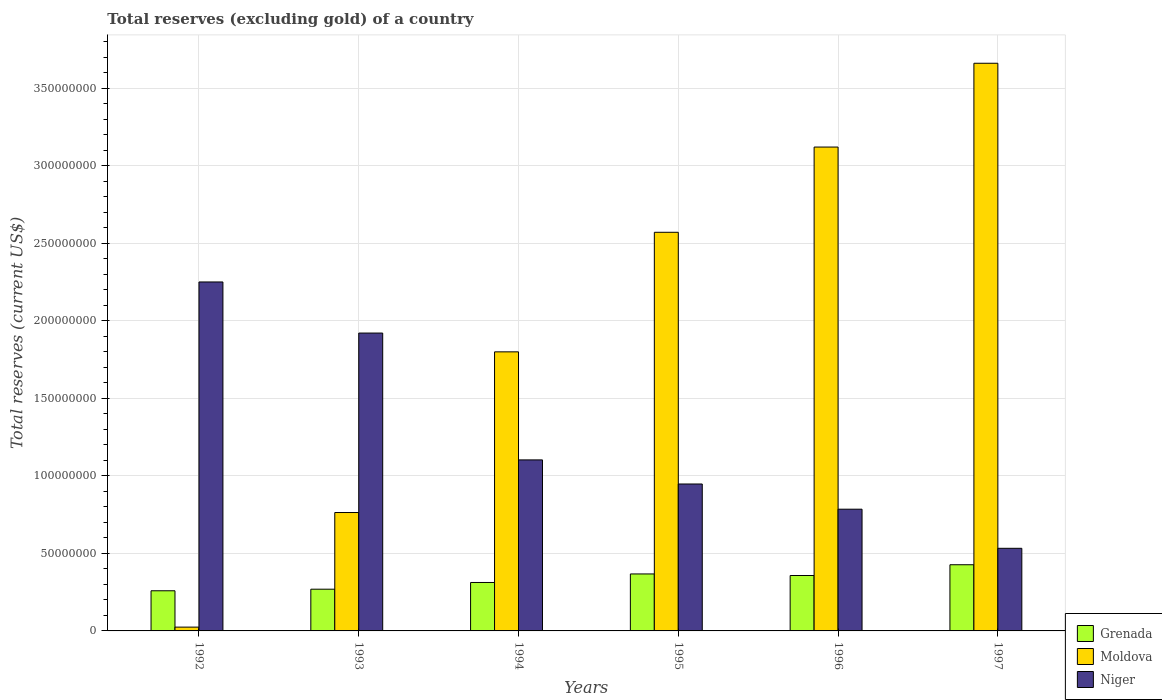How many groups of bars are there?
Offer a terse response. 6. Are the number of bars per tick equal to the number of legend labels?
Ensure brevity in your answer.  Yes. How many bars are there on the 4th tick from the left?
Your answer should be compact. 3. How many bars are there on the 6th tick from the right?
Your answer should be very brief. 3. What is the label of the 5th group of bars from the left?
Ensure brevity in your answer.  1996. In how many cases, is the number of bars for a given year not equal to the number of legend labels?
Provide a succinct answer. 0. What is the total reserves (excluding gold) in Niger in 1993?
Make the answer very short. 1.92e+08. Across all years, what is the maximum total reserves (excluding gold) in Niger?
Offer a terse response. 2.25e+08. Across all years, what is the minimum total reserves (excluding gold) in Moldova?
Make the answer very short. 2.45e+06. In which year was the total reserves (excluding gold) in Niger minimum?
Your response must be concise. 1997. What is the total total reserves (excluding gold) in Moldova in the graph?
Provide a short and direct response. 1.19e+09. What is the difference between the total reserves (excluding gold) in Niger in 1994 and that in 1997?
Your response must be concise. 5.70e+07. What is the difference between the total reserves (excluding gold) in Grenada in 1992 and the total reserves (excluding gold) in Moldova in 1995?
Offer a very short reply. -2.31e+08. What is the average total reserves (excluding gold) in Moldova per year?
Keep it short and to the point. 1.99e+08. In the year 1992, what is the difference between the total reserves (excluding gold) in Niger and total reserves (excluding gold) in Grenada?
Make the answer very short. 1.99e+08. In how many years, is the total reserves (excluding gold) in Grenada greater than 60000000 US$?
Keep it short and to the point. 0. What is the ratio of the total reserves (excluding gold) in Moldova in 1995 to that in 1997?
Offer a terse response. 0.7. Is the total reserves (excluding gold) in Grenada in 1994 less than that in 1997?
Provide a succinct answer. Yes. What is the difference between the highest and the second highest total reserves (excluding gold) in Moldova?
Give a very brief answer. 5.40e+07. What is the difference between the highest and the lowest total reserves (excluding gold) in Niger?
Make the answer very short. 1.72e+08. What does the 1st bar from the left in 1992 represents?
Your answer should be compact. Grenada. What does the 1st bar from the right in 1993 represents?
Provide a short and direct response. Niger. How many years are there in the graph?
Give a very brief answer. 6. Are the values on the major ticks of Y-axis written in scientific E-notation?
Make the answer very short. No. Does the graph contain any zero values?
Make the answer very short. No. How many legend labels are there?
Your answer should be very brief. 3. How are the legend labels stacked?
Provide a succinct answer. Vertical. What is the title of the graph?
Your answer should be compact. Total reserves (excluding gold) of a country. What is the label or title of the Y-axis?
Your answer should be compact. Total reserves (current US$). What is the Total reserves (current US$) of Grenada in 1992?
Offer a very short reply. 2.59e+07. What is the Total reserves (current US$) in Moldova in 1992?
Give a very brief answer. 2.45e+06. What is the Total reserves (current US$) of Niger in 1992?
Give a very brief answer. 2.25e+08. What is the Total reserves (current US$) in Grenada in 1993?
Make the answer very short. 2.69e+07. What is the Total reserves (current US$) in Moldova in 1993?
Make the answer very short. 7.63e+07. What is the Total reserves (current US$) of Niger in 1993?
Ensure brevity in your answer.  1.92e+08. What is the Total reserves (current US$) of Grenada in 1994?
Your response must be concise. 3.12e+07. What is the Total reserves (current US$) in Moldova in 1994?
Ensure brevity in your answer.  1.80e+08. What is the Total reserves (current US$) in Niger in 1994?
Ensure brevity in your answer.  1.10e+08. What is the Total reserves (current US$) of Grenada in 1995?
Your response must be concise. 3.67e+07. What is the Total reserves (current US$) of Moldova in 1995?
Your answer should be very brief. 2.57e+08. What is the Total reserves (current US$) of Niger in 1995?
Offer a very short reply. 9.47e+07. What is the Total reserves (current US$) in Grenada in 1996?
Your response must be concise. 3.57e+07. What is the Total reserves (current US$) in Moldova in 1996?
Make the answer very short. 3.12e+08. What is the Total reserves (current US$) in Niger in 1996?
Provide a succinct answer. 7.85e+07. What is the Total reserves (current US$) in Grenada in 1997?
Your answer should be very brief. 4.27e+07. What is the Total reserves (current US$) of Moldova in 1997?
Your response must be concise. 3.66e+08. What is the Total reserves (current US$) in Niger in 1997?
Provide a short and direct response. 5.33e+07. Across all years, what is the maximum Total reserves (current US$) in Grenada?
Keep it short and to the point. 4.27e+07. Across all years, what is the maximum Total reserves (current US$) in Moldova?
Your answer should be compact. 3.66e+08. Across all years, what is the maximum Total reserves (current US$) of Niger?
Ensure brevity in your answer.  2.25e+08. Across all years, what is the minimum Total reserves (current US$) in Grenada?
Offer a very short reply. 2.59e+07. Across all years, what is the minimum Total reserves (current US$) in Moldova?
Keep it short and to the point. 2.45e+06. Across all years, what is the minimum Total reserves (current US$) of Niger?
Keep it short and to the point. 5.33e+07. What is the total Total reserves (current US$) in Grenada in the graph?
Make the answer very short. 1.99e+08. What is the total Total reserves (current US$) of Moldova in the graph?
Keep it short and to the point. 1.19e+09. What is the total Total reserves (current US$) of Niger in the graph?
Offer a very short reply. 7.54e+08. What is the difference between the Total reserves (current US$) in Grenada in 1992 and that in 1993?
Ensure brevity in your answer.  -1.02e+06. What is the difference between the Total reserves (current US$) in Moldova in 1992 and that in 1993?
Ensure brevity in your answer.  -7.39e+07. What is the difference between the Total reserves (current US$) in Niger in 1992 and that in 1993?
Provide a succinct answer. 3.29e+07. What is the difference between the Total reserves (current US$) of Grenada in 1992 and that in 1994?
Make the answer very short. -5.35e+06. What is the difference between the Total reserves (current US$) in Moldova in 1992 and that in 1994?
Provide a succinct answer. -1.77e+08. What is the difference between the Total reserves (current US$) of Niger in 1992 and that in 1994?
Your answer should be compact. 1.15e+08. What is the difference between the Total reserves (current US$) in Grenada in 1992 and that in 1995?
Your answer should be compact. -1.09e+07. What is the difference between the Total reserves (current US$) in Moldova in 1992 and that in 1995?
Provide a succinct answer. -2.55e+08. What is the difference between the Total reserves (current US$) in Niger in 1992 and that in 1995?
Provide a succinct answer. 1.30e+08. What is the difference between the Total reserves (current US$) in Grenada in 1992 and that in 1996?
Provide a short and direct response. -9.85e+06. What is the difference between the Total reserves (current US$) in Moldova in 1992 and that in 1996?
Your answer should be compact. -3.10e+08. What is the difference between the Total reserves (current US$) in Niger in 1992 and that in 1996?
Ensure brevity in your answer.  1.46e+08. What is the difference between the Total reserves (current US$) of Grenada in 1992 and that in 1997?
Provide a succinct answer. -1.68e+07. What is the difference between the Total reserves (current US$) of Moldova in 1992 and that in 1997?
Your answer should be compact. -3.64e+08. What is the difference between the Total reserves (current US$) of Niger in 1992 and that in 1997?
Provide a short and direct response. 1.72e+08. What is the difference between the Total reserves (current US$) of Grenada in 1993 and that in 1994?
Provide a short and direct response. -4.33e+06. What is the difference between the Total reserves (current US$) in Moldova in 1993 and that in 1994?
Ensure brevity in your answer.  -1.04e+08. What is the difference between the Total reserves (current US$) of Niger in 1993 and that in 1994?
Make the answer very short. 8.18e+07. What is the difference between the Total reserves (current US$) of Grenada in 1993 and that in 1995?
Offer a terse response. -9.83e+06. What is the difference between the Total reserves (current US$) of Moldova in 1993 and that in 1995?
Provide a succinct answer. -1.81e+08. What is the difference between the Total reserves (current US$) in Niger in 1993 and that in 1995?
Ensure brevity in your answer.  9.73e+07. What is the difference between the Total reserves (current US$) of Grenada in 1993 and that in 1996?
Ensure brevity in your answer.  -8.83e+06. What is the difference between the Total reserves (current US$) in Moldova in 1993 and that in 1996?
Your response must be concise. -2.36e+08. What is the difference between the Total reserves (current US$) in Niger in 1993 and that in 1996?
Make the answer very short. 1.14e+08. What is the difference between the Total reserves (current US$) in Grenada in 1993 and that in 1997?
Provide a succinct answer. -1.58e+07. What is the difference between the Total reserves (current US$) of Moldova in 1993 and that in 1997?
Provide a short and direct response. -2.90e+08. What is the difference between the Total reserves (current US$) in Niger in 1993 and that in 1997?
Your answer should be very brief. 1.39e+08. What is the difference between the Total reserves (current US$) of Grenada in 1994 and that in 1995?
Offer a very short reply. -5.50e+06. What is the difference between the Total reserves (current US$) in Moldova in 1994 and that in 1995?
Make the answer very short. -7.71e+07. What is the difference between the Total reserves (current US$) of Niger in 1994 and that in 1995?
Ensure brevity in your answer.  1.55e+07. What is the difference between the Total reserves (current US$) in Grenada in 1994 and that in 1996?
Your answer should be very brief. -4.50e+06. What is the difference between the Total reserves (current US$) in Moldova in 1994 and that in 1996?
Your response must be concise. -1.32e+08. What is the difference between the Total reserves (current US$) of Niger in 1994 and that in 1996?
Offer a very short reply. 3.18e+07. What is the difference between the Total reserves (current US$) in Grenada in 1994 and that in 1997?
Offer a terse response. -1.14e+07. What is the difference between the Total reserves (current US$) in Moldova in 1994 and that in 1997?
Offer a terse response. -1.86e+08. What is the difference between the Total reserves (current US$) of Niger in 1994 and that in 1997?
Keep it short and to the point. 5.70e+07. What is the difference between the Total reserves (current US$) of Grenada in 1995 and that in 1996?
Keep it short and to the point. 1.01e+06. What is the difference between the Total reserves (current US$) of Moldova in 1995 and that in 1996?
Your answer should be compact. -5.49e+07. What is the difference between the Total reserves (current US$) of Niger in 1995 and that in 1996?
Make the answer very short. 1.62e+07. What is the difference between the Total reserves (current US$) in Grenada in 1995 and that in 1997?
Provide a short and direct response. -5.93e+06. What is the difference between the Total reserves (current US$) in Moldova in 1995 and that in 1997?
Provide a succinct answer. -1.09e+08. What is the difference between the Total reserves (current US$) of Niger in 1995 and that in 1997?
Provide a short and direct response. 4.15e+07. What is the difference between the Total reserves (current US$) in Grenada in 1996 and that in 1997?
Your answer should be compact. -6.94e+06. What is the difference between the Total reserves (current US$) of Moldova in 1996 and that in 1997?
Your response must be concise. -5.40e+07. What is the difference between the Total reserves (current US$) in Niger in 1996 and that in 1997?
Offer a terse response. 2.52e+07. What is the difference between the Total reserves (current US$) of Grenada in 1992 and the Total reserves (current US$) of Moldova in 1993?
Keep it short and to the point. -5.05e+07. What is the difference between the Total reserves (current US$) in Grenada in 1992 and the Total reserves (current US$) in Niger in 1993?
Offer a terse response. -1.66e+08. What is the difference between the Total reserves (current US$) of Moldova in 1992 and the Total reserves (current US$) of Niger in 1993?
Offer a very short reply. -1.90e+08. What is the difference between the Total reserves (current US$) of Grenada in 1992 and the Total reserves (current US$) of Moldova in 1994?
Your answer should be very brief. -1.54e+08. What is the difference between the Total reserves (current US$) in Grenada in 1992 and the Total reserves (current US$) in Niger in 1994?
Offer a very short reply. -8.44e+07. What is the difference between the Total reserves (current US$) of Moldova in 1992 and the Total reserves (current US$) of Niger in 1994?
Offer a very short reply. -1.08e+08. What is the difference between the Total reserves (current US$) of Grenada in 1992 and the Total reserves (current US$) of Moldova in 1995?
Provide a short and direct response. -2.31e+08. What is the difference between the Total reserves (current US$) in Grenada in 1992 and the Total reserves (current US$) in Niger in 1995?
Your answer should be very brief. -6.88e+07. What is the difference between the Total reserves (current US$) in Moldova in 1992 and the Total reserves (current US$) in Niger in 1995?
Offer a very short reply. -9.23e+07. What is the difference between the Total reserves (current US$) of Grenada in 1992 and the Total reserves (current US$) of Moldova in 1996?
Provide a short and direct response. -2.86e+08. What is the difference between the Total reserves (current US$) of Grenada in 1992 and the Total reserves (current US$) of Niger in 1996?
Your response must be concise. -5.26e+07. What is the difference between the Total reserves (current US$) in Moldova in 1992 and the Total reserves (current US$) in Niger in 1996?
Your answer should be compact. -7.60e+07. What is the difference between the Total reserves (current US$) of Grenada in 1992 and the Total reserves (current US$) of Moldova in 1997?
Keep it short and to the point. -3.40e+08. What is the difference between the Total reserves (current US$) in Grenada in 1992 and the Total reserves (current US$) in Niger in 1997?
Make the answer very short. -2.74e+07. What is the difference between the Total reserves (current US$) in Moldova in 1992 and the Total reserves (current US$) in Niger in 1997?
Provide a short and direct response. -5.08e+07. What is the difference between the Total reserves (current US$) of Grenada in 1993 and the Total reserves (current US$) of Moldova in 1994?
Provide a succinct answer. -1.53e+08. What is the difference between the Total reserves (current US$) in Grenada in 1993 and the Total reserves (current US$) in Niger in 1994?
Ensure brevity in your answer.  -8.34e+07. What is the difference between the Total reserves (current US$) in Moldova in 1993 and the Total reserves (current US$) in Niger in 1994?
Give a very brief answer. -3.39e+07. What is the difference between the Total reserves (current US$) of Grenada in 1993 and the Total reserves (current US$) of Moldova in 1995?
Your response must be concise. -2.30e+08. What is the difference between the Total reserves (current US$) of Grenada in 1993 and the Total reserves (current US$) of Niger in 1995?
Your response must be concise. -6.78e+07. What is the difference between the Total reserves (current US$) of Moldova in 1993 and the Total reserves (current US$) of Niger in 1995?
Offer a terse response. -1.84e+07. What is the difference between the Total reserves (current US$) of Grenada in 1993 and the Total reserves (current US$) of Moldova in 1996?
Your answer should be very brief. -2.85e+08. What is the difference between the Total reserves (current US$) in Grenada in 1993 and the Total reserves (current US$) in Niger in 1996?
Provide a short and direct response. -5.16e+07. What is the difference between the Total reserves (current US$) in Moldova in 1993 and the Total reserves (current US$) in Niger in 1996?
Offer a very short reply. -2.15e+06. What is the difference between the Total reserves (current US$) of Grenada in 1993 and the Total reserves (current US$) of Moldova in 1997?
Provide a short and direct response. -3.39e+08. What is the difference between the Total reserves (current US$) of Grenada in 1993 and the Total reserves (current US$) of Niger in 1997?
Make the answer very short. -2.64e+07. What is the difference between the Total reserves (current US$) of Moldova in 1993 and the Total reserves (current US$) of Niger in 1997?
Provide a short and direct response. 2.31e+07. What is the difference between the Total reserves (current US$) in Grenada in 1994 and the Total reserves (current US$) in Moldova in 1995?
Provide a short and direct response. -2.26e+08. What is the difference between the Total reserves (current US$) of Grenada in 1994 and the Total reserves (current US$) of Niger in 1995?
Your answer should be very brief. -6.35e+07. What is the difference between the Total reserves (current US$) in Moldova in 1994 and the Total reserves (current US$) in Niger in 1995?
Your answer should be compact. 8.52e+07. What is the difference between the Total reserves (current US$) of Grenada in 1994 and the Total reserves (current US$) of Moldova in 1996?
Your answer should be compact. -2.81e+08. What is the difference between the Total reserves (current US$) of Grenada in 1994 and the Total reserves (current US$) of Niger in 1996?
Ensure brevity in your answer.  -4.73e+07. What is the difference between the Total reserves (current US$) in Moldova in 1994 and the Total reserves (current US$) in Niger in 1996?
Provide a short and direct response. 1.01e+08. What is the difference between the Total reserves (current US$) of Grenada in 1994 and the Total reserves (current US$) of Moldova in 1997?
Ensure brevity in your answer.  -3.35e+08. What is the difference between the Total reserves (current US$) in Grenada in 1994 and the Total reserves (current US$) in Niger in 1997?
Give a very brief answer. -2.20e+07. What is the difference between the Total reserves (current US$) in Moldova in 1994 and the Total reserves (current US$) in Niger in 1997?
Your answer should be very brief. 1.27e+08. What is the difference between the Total reserves (current US$) in Grenada in 1995 and the Total reserves (current US$) in Moldova in 1996?
Ensure brevity in your answer.  -2.75e+08. What is the difference between the Total reserves (current US$) of Grenada in 1995 and the Total reserves (current US$) of Niger in 1996?
Offer a terse response. -4.17e+07. What is the difference between the Total reserves (current US$) of Moldova in 1995 and the Total reserves (current US$) of Niger in 1996?
Offer a very short reply. 1.79e+08. What is the difference between the Total reserves (current US$) of Grenada in 1995 and the Total reserves (current US$) of Moldova in 1997?
Your answer should be very brief. -3.29e+08. What is the difference between the Total reserves (current US$) of Grenada in 1995 and the Total reserves (current US$) of Niger in 1997?
Make the answer very short. -1.65e+07. What is the difference between the Total reserves (current US$) of Moldova in 1995 and the Total reserves (current US$) of Niger in 1997?
Keep it short and to the point. 2.04e+08. What is the difference between the Total reserves (current US$) in Grenada in 1996 and the Total reserves (current US$) in Moldova in 1997?
Offer a very short reply. -3.30e+08. What is the difference between the Total reserves (current US$) of Grenada in 1996 and the Total reserves (current US$) of Niger in 1997?
Your response must be concise. -1.75e+07. What is the difference between the Total reserves (current US$) of Moldova in 1996 and the Total reserves (current US$) of Niger in 1997?
Make the answer very short. 2.59e+08. What is the average Total reserves (current US$) of Grenada per year?
Keep it short and to the point. 3.32e+07. What is the average Total reserves (current US$) in Moldova per year?
Ensure brevity in your answer.  1.99e+08. What is the average Total reserves (current US$) in Niger per year?
Keep it short and to the point. 1.26e+08. In the year 1992, what is the difference between the Total reserves (current US$) in Grenada and Total reserves (current US$) in Moldova?
Provide a succinct answer. 2.34e+07. In the year 1992, what is the difference between the Total reserves (current US$) of Grenada and Total reserves (current US$) of Niger?
Make the answer very short. -1.99e+08. In the year 1992, what is the difference between the Total reserves (current US$) in Moldova and Total reserves (current US$) in Niger?
Your answer should be very brief. -2.23e+08. In the year 1993, what is the difference between the Total reserves (current US$) in Grenada and Total reserves (current US$) in Moldova?
Offer a very short reply. -4.94e+07. In the year 1993, what is the difference between the Total reserves (current US$) in Grenada and Total reserves (current US$) in Niger?
Your answer should be compact. -1.65e+08. In the year 1993, what is the difference between the Total reserves (current US$) of Moldova and Total reserves (current US$) of Niger?
Keep it short and to the point. -1.16e+08. In the year 1994, what is the difference between the Total reserves (current US$) of Grenada and Total reserves (current US$) of Moldova?
Give a very brief answer. -1.49e+08. In the year 1994, what is the difference between the Total reserves (current US$) of Grenada and Total reserves (current US$) of Niger?
Your answer should be very brief. -7.90e+07. In the year 1994, what is the difference between the Total reserves (current US$) of Moldova and Total reserves (current US$) of Niger?
Offer a terse response. 6.97e+07. In the year 1995, what is the difference between the Total reserves (current US$) of Grenada and Total reserves (current US$) of Moldova?
Your response must be concise. -2.20e+08. In the year 1995, what is the difference between the Total reserves (current US$) of Grenada and Total reserves (current US$) of Niger?
Your answer should be compact. -5.80e+07. In the year 1995, what is the difference between the Total reserves (current US$) in Moldova and Total reserves (current US$) in Niger?
Provide a succinct answer. 1.62e+08. In the year 1996, what is the difference between the Total reserves (current US$) of Grenada and Total reserves (current US$) of Moldova?
Provide a short and direct response. -2.76e+08. In the year 1996, what is the difference between the Total reserves (current US$) in Grenada and Total reserves (current US$) in Niger?
Ensure brevity in your answer.  -4.28e+07. In the year 1996, what is the difference between the Total reserves (current US$) of Moldova and Total reserves (current US$) of Niger?
Ensure brevity in your answer.  2.33e+08. In the year 1997, what is the difference between the Total reserves (current US$) of Grenada and Total reserves (current US$) of Moldova?
Your response must be concise. -3.23e+08. In the year 1997, what is the difference between the Total reserves (current US$) of Grenada and Total reserves (current US$) of Niger?
Your answer should be compact. -1.06e+07. In the year 1997, what is the difference between the Total reserves (current US$) in Moldova and Total reserves (current US$) in Niger?
Make the answer very short. 3.13e+08. What is the ratio of the Total reserves (current US$) of Grenada in 1992 to that in 1993?
Provide a short and direct response. 0.96. What is the ratio of the Total reserves (current US$) in Moldova in 1992 to that in 1993?
Give a very brief answer. 0.03. What is the ratio of the Total reserves (current US$) of Niger in 1992 to that in 1993?
Your answer should be compact. 1.17. What is the ratio of the Total reserves (current US$) of Grenada in 1992 to that in 1994?
Offer a very short reply. 0.83. What is the ratio of the Total reserves (current US$) in Moldova in 1992 to that in 1994?
Give a very brief answer. 0.01. What is the ratio of the Total reserves (current US$) of Niger in 1992 to that in 1994?
Ensure brevity in your answer.  2.04. What is the ratio of the Total reserves (current US$) in Grenada in 1992 to that in 1995?
Provide a succinct answer. 0.7. What is the ratio of the Total reserves (current US$) in Moldova in 1992 to that in 1995?
Provide a short and direct response. 0.01. What is the ratio of the Total reserves (current US$) of Niger in 1992 to that in 1995?
Offer a terse response. 2.38. What is the ratio of the Total reserves (current US$) in Grenada in 1992 to that in 1996?
Ensure brevity in your answer.  0.72. What is the ratio of the Total reserves (current US$) in Moldova in 1992 to that in 1996?
Your response must be concise. 0.01. What is the ratio of the Total reserves (current US$) in Niger in 1992 to that in 1996?
Make the answer very short. 2.87. What is the ratio of the Total reserves (current US$) of Grenada in 1992 to that in 1997?
Keep it short and to the point. 0.61. What is the ratio of the Total reserves (current US$) in Moldova in 1992 to that in 1997?
Your answer should be compact. 0.01. What is the ratio of the Total reserves (current US$) in Niger in 1992 to that in 1997?
Your answer should be very brief. 4.22. What is the ratio of the Total reserves (current US$) of Grenada in 1993 to that in 1994?
Keep it short and to the point. 0.86. What is the ratio of the Total reserves (current US$) in Moldova in 1993 to that in 1994?
Offer a very short reply. 0.42. What is the ratio of the Total reserves (current US$) of Niger in 1993 to that in 1994?
Provide a succinct answer. 1.74. What is the ratio of the Total reserves (current US$) in Grenada in 1993 to that in 1995?
Give a very brief answer. 0.73. What is the ratio of the Total reserves (current US$) of Moldova in 1993 to that in 1995?
Provide a short and direct response. 0.3. What is the ratio of the Total reserves (current US$) in Niger in 1993 to that in 1995?
Your answer should be very brief. 2.03. What is the ratio of the Total reserves (current US$) of Grenada in 1993 to that in 1996?
Offer a very short reply. 0.75. What is the ratio of the Total reserves (current US$) in Moldova in 1993 to that in 1996?
Your answer should be compact. 0.24. What is the ratio of the Total reserves (current US$) of Niger in 1993 to that in 1996?
Your answer should be very brief. 2.45. What is the ratio of the Total reserves (current US$) in Grenada in 1993 to that in 1997?
Give a very brief answer. 0.63. What is the ratio of the Total reserves (current US$) in Moldova in 1993 to that in 1997?
Your response must be concise. 0.21. What is the ratio of the Total reserves (current US$) in Niger in 1993 to that in 1997?
Make the answer very short. 3.61. What is the ratio of the Total reserves (current US$) in Grenada in 1994 to that in 1995?
Your answer should be compact. 0.85. What is the ratio of the Total reserves (current US$) of Moldova in 1994 to that in 1995?
Provide a succinct answer. 0.7. What is the ratio of the Total reserves (current US$) in Niger in 1994 to that in 1995?
Ensure brevity in your answer.  1.16. What is the ratio of the Total reserves (current US$) of Grenada in 1994 to that in 1996?
Provide a succinct answer. 0.87. What is the ratio of the Total reserves (current US$) of Moldova in 1994 to that in 1996?
Your response must be concise. 0.58. What is the ratio of the Total reserves (current US$) of Niger in 1994 to that in 1996?
Provide a short and direct response. 1.4. What is the ratio of the Total reserves (current US$) of Grenada in 1994 to that in 1997?
Ensure brevity in your answer.  0.73. What is the ratio of the Total reserves (current US$) of Moldova in 1994 to that in 1997?
Provide a succinct answer. 0.49. What is the ratio of the Total reserves (current US$) of Niger in 1994 to that in 1997?
Give a very brief answer. 2.07. What is the ratio of the Total reserves (current US$) of Grenada in 1995 to that in 1996?
Your response must be concise. 1.03. What is the ratio of the Total reserves (current US$) of Moldova in 1995 to that in 1996?
Give a very brief answer. 0.82. What is the ratio of the Total reserves (current US$) in Niger in 1995 to that in 1996?
Keep it short and to the point. 1.21. What is the ratio of the Total reserves (current US$) in Grenada in 1995 to that in 1997?
Keep it short and to the point. 0.86. What is the ratio of the Total reserves (current US$) of Moldova in 1995 to that in 1997?
Make the answer very short. 0.7. What is the ratio of the Total reserves (current US$) in Niger in 1995 to that in 1997?
Offer a very short reply. 1.78. What is the ratio of the Total reserves (current US$) in Grenada in 1996 to that in 1997?
Offer a very short reply. 0.84. What is the ratio of the Total reserves (current US$) of Moldova in 1996 to that in 1997?
Your answer should be very brief. 0.85. What is the ratio of the Total reserves (current US$) in Niger in 1996 to that in 1997?
Your answer should be very brief. 1.47. What is the difference between the highest and the second highest Total reserves (current US$) in Grenada?
Your response must be concise. 5.93e+06. What is the difference between the highest and the second highest Total reserves (current US$) in Moldova?
Your answer should be compact. 5.40e+07. What is the difference between the highest and the second highest Total reserves (current US$) of Niger?
Offer a very short reply. 3.29e+07. What is the difference between the highest and the lowest Total reserves (current US$) in Grenada?
Your response must be concise. 1.68e+07. What is the difference between the highest and the lowest Total reserves (current US$) of Moldova?
Ensure brevity in your answer.  3.64e+08. What is the difference between the highest and the lowest Total reserves (current US$) of Niger?
Provide a short and direct response. 1.72e+08. 